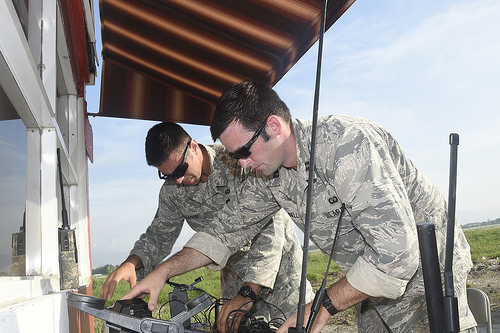<image>
Is there a man in front of the pole? No. The man is not in front of the pole. The spatial positioning shows a different relationship between these objects. Is the man above the sky? Yes. The man is positioned above the sky in the vertical space, higher up in the scene. 